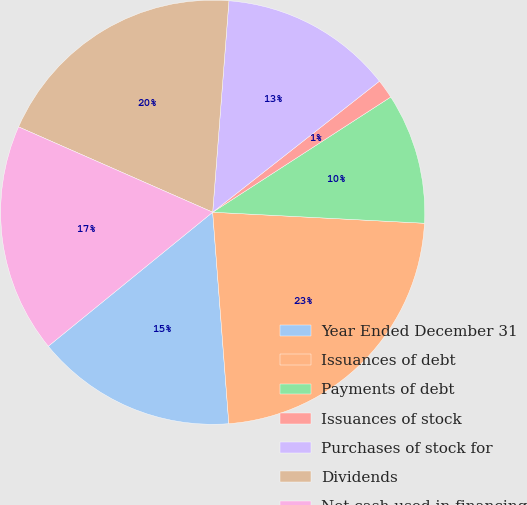Convert chart. <chart><loc_0><loc_0><loc_500><loc_500><pie_chart><fcel>Year Ended December 31<fcel>Issuances of debt<fcel>Payments of debt<fcel>Issuances of stock<fcel>Purchases of stock for<fcel>Dividends<fcel>Net cash used in financing<nl><fcel>15.33%<fcel>22.96%<fcel>9.97%<fcel>1.46%<fcel>13.18%<fcel>19.63%<fcel>17.48%<nl></chart> 